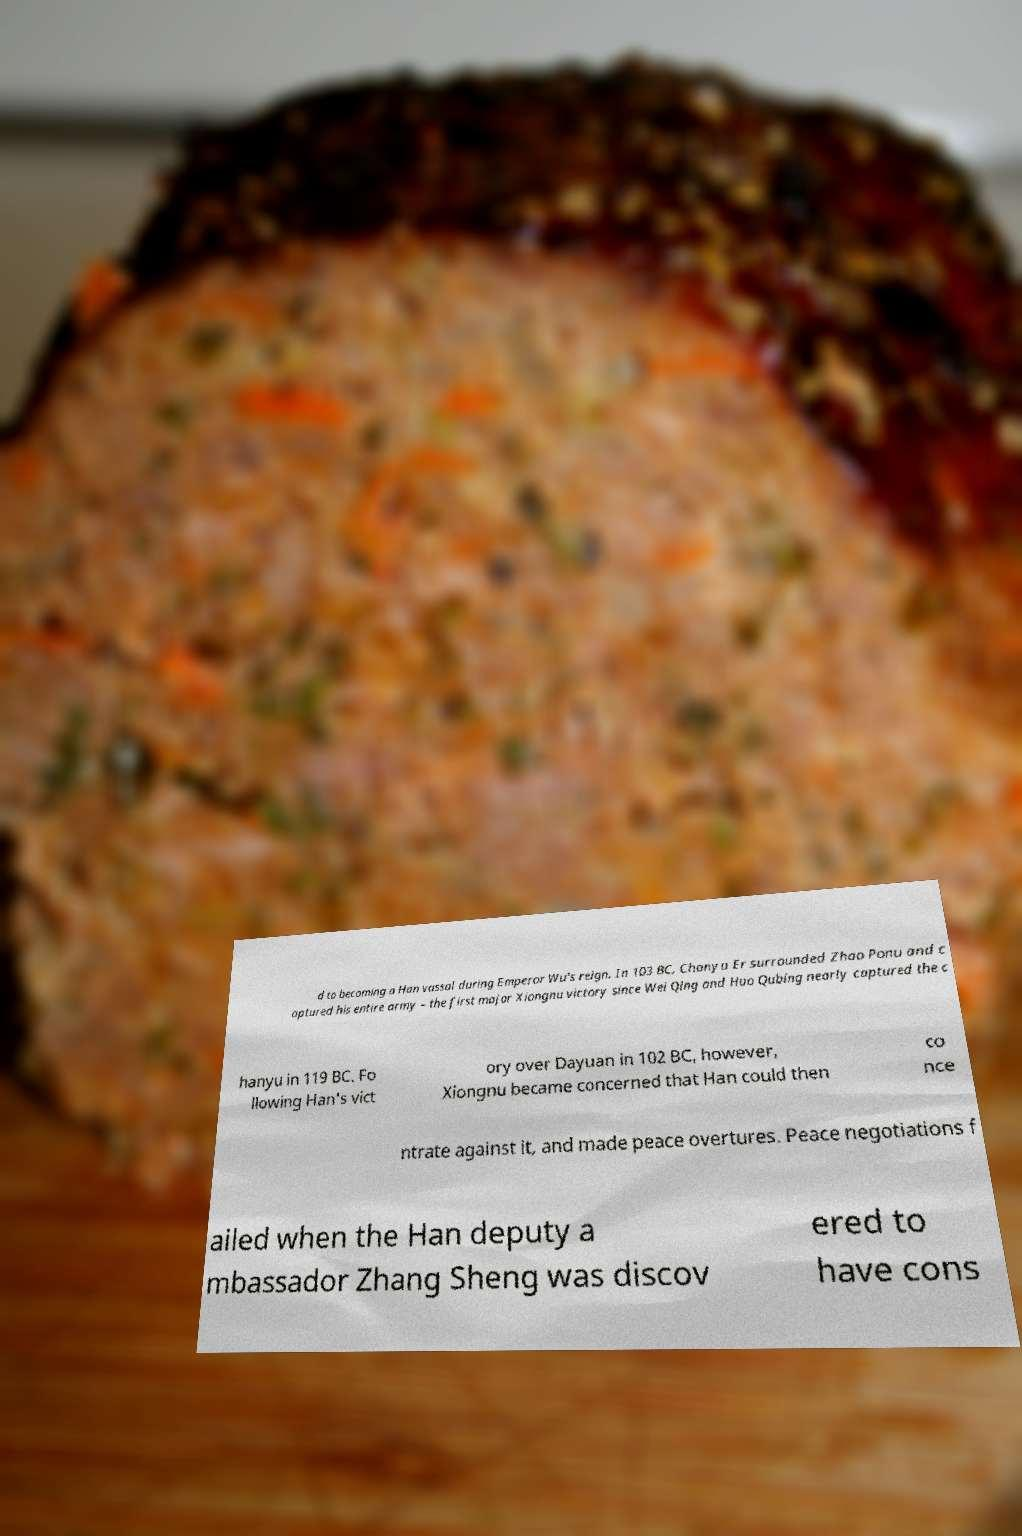Can you accurately transcribe the text from the provided image for me? d to becoming a Han vassal during Emperor Wu's reign. In 103 BC, Chanyu Er surrounded Zhao Ponu and c aptured his entire army – the first major Xiongnu victory since Wei Qing and Huo Qubing nearly captured the c hanyu in 119 BC. Fo llowing Han's vict ory over Dayuan in 102 BC, however, Xiongnu became concerned that Han could then co nce ntrate against it, and made peace overtures. Peace negotiations f ailed when the Han deputy a mbassador Zhang Sheng was discov ered to have cons 